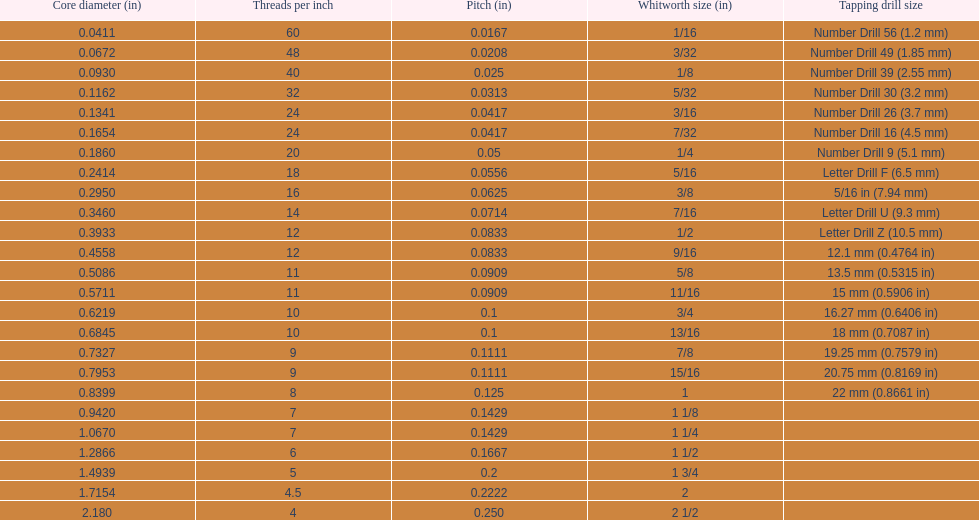What core diameter (in) comes after 0.0930? 0.1162. 